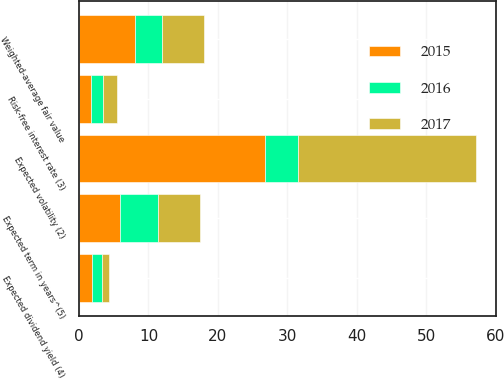Convert chart. <chart><loc_0><loc_0><loc_500><loc_500><stacked_bar_chart><ecel><fcel>Weighted-average fair value<fcel>Expected volatility (2)<fcel>Risk-free interest rate (3)<fcel>Expected dividend yield (4)<fcel>Expected term in years^(5)<nl><fcel>2017<fcel>6<fcel>25.7<fcel>2<fcel>1<fcel>6.1<nl><fcel>2016<fcel>4<fcel>4.7<fcel>1.7<fcel>1.5<fcel>5.4<nl><fcel>2015<fcel>8<fcel>26.8<fcel>1.7<fcel>1.8<fcel>5.9<nl></chart> 